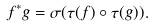<formula> <loc_0><loc_0><loc_500><loc_500>f ^ { * } g = \sigma ( \tau ( f ) \circ \tau ( g ) ) .</formula> 